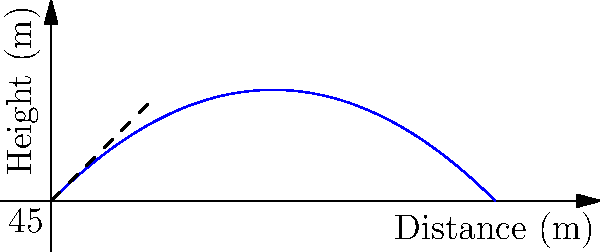In a city planning simulation, you're tasked with designing a water fountain for a new park. The fountain shoots water at an initial velocity of 30 m/s at a 45-degree angle from the horizontal. Assuming air resistance is negligible, what is the maximum height reached by the water stream? Let's approach this step-by-step:

1) The maximum height is reached when the vertical velocity becomes zero. We can use the equation:

   $v_y = v_0 \sin \theta - gt$

   Where $v_y$ is the vertical velocity, $v_0$ is the initial velocity, $\theta$ is the angle, $g$ is the acceleration due to gravity, and $t$ is the time.

2) At the highest point, $v_y = 0$, so:

   $0 = v_0 \sin \theta - gt_{\text{max}}$

3) Solving for $t_{\text{max}}$:

   $t_{\text{max}} = \frac{v_0 \sin \theta}{g}$

4) Now, we can use the equation for the height:

   $h = v_0 \sin \theta \cdot t - \frac{1}{2}gt^2$

5) Substituting $t_{\text{max}}$ into this equation:

   $h_{\text{max}} = v_0 \sin \theta \cdot \frac{v_0 \sin \theta}{g} - \frac{1}{2}g(\frac{v_0 \sin \theta}{g})^2$

6) Simplifying:

   $h_{\text{max}} = \frac{v_0^2 \sin^2 \theta}{g} - \frac{v_0^2 \sin^2 \theta}{2g} = \frac{v_0^2 \sin^2 \theta}{2g}$

7) Now, let's plug in our values:
   $v_0 = 30$ m/s
   $\theta = 45°$
   $g = 9.8$ m/s²

   $h_{\text{max}} = \frac{30^2 \cdot \sin^2(45°)}{2 \cdot 9.8} = \frac{900 \cdot 0.5}{19.6} \approx 22.96$ m

Therefore, the maximum height reached by the water stream is approximately 22.96 meters.
Answer: 22.96 m 